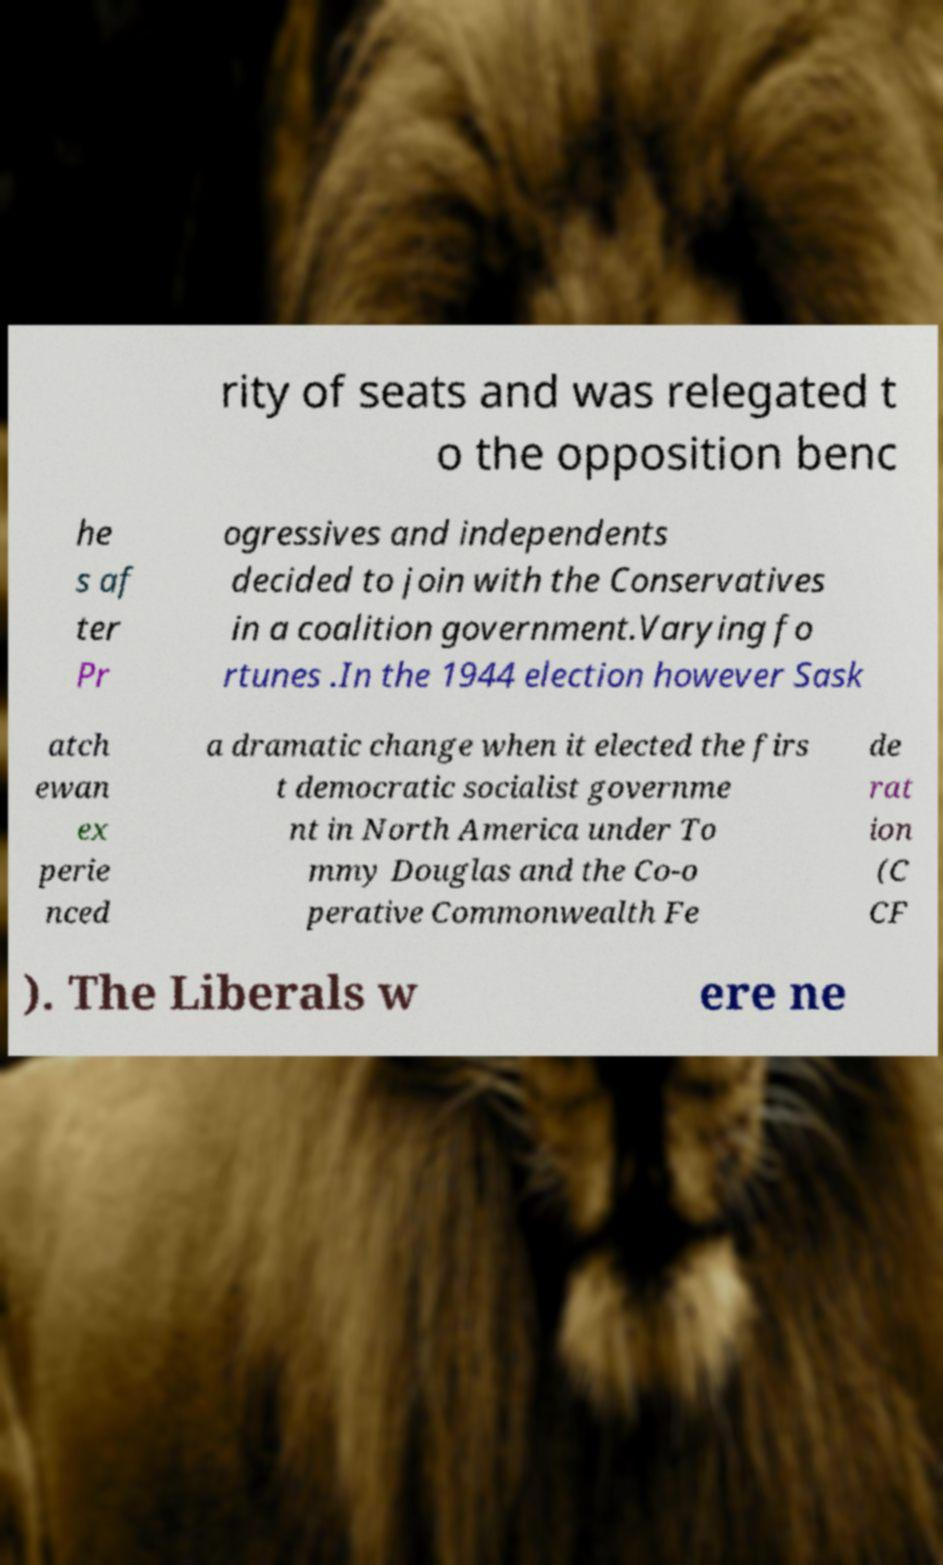For documentation purposes, I need the text within this image transcribed. Could you provide that? rity of seats and was relegated t o the opposition benc he s af ter Pr ogressives and independents decided to join with the Conservatives in a coalition government.Varying fo rtunes .In the 1944 election however Sask atch ewan ex perie nced a dramatic change when it elected the firs t democratic socialist governme nt in North America under To mmy Douglas and the Co-o perative Commonwealth Fe de rat ion (C CF ). The Liberals w ere ne 